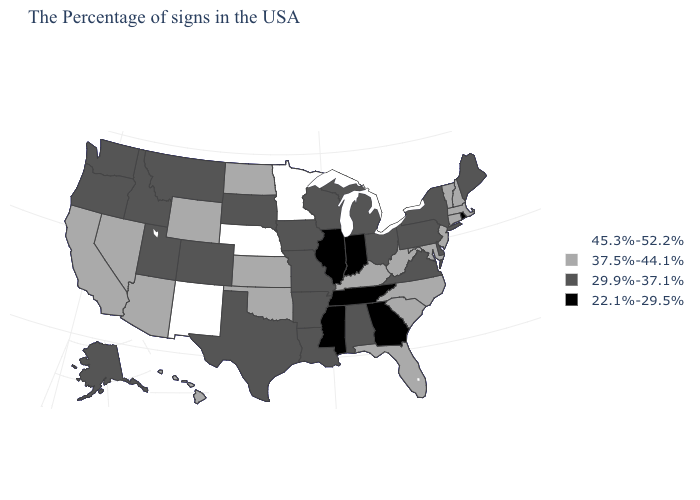Which states hav the highest value in the MidWest?
Give a very brief answer. Minnesota, Nebraska. What is the value of Delaware?
Concise answer only. 29.9%-37.1%. Which states have the lowest value in the USA?
Keep it brief. Rhode Island, Georgia, Indiana, Tennessee, Illinois, Mississippi. Name the states that have a value in the range 45.3%-52.2%?
Quick response, please. Minnesota, Nebraska, New Mexico. What is the value of Hawaii?
Be succinct. 37.5%-44.1%. Among the states that border Indiana , which have the highest value?
Concise answer only. Kentucky. Does Colorado have the lowest value in the USA?
Answer briefly. No. Does Oklahoma have a lower value than Massachusetts?
Be succinct. No. What is the value of Tennessee?
Short answer required. 22.1%-29.5%. Name the states that have a value in the range 29.9%-37.1%?
Answer briefly. Maine, New York, Delaware, Pennsylvania, Virginia, Ohio, Michigan, Alabama, Wisconsin, Louisiana, Missouri, Arkansas, Iowa, Texas, South Dakota, Colorado, Utah, Montana, Idaho, Washington, Oregon, Alaska. What is the value of Montana?
Concise answer only. 29.9%-37.1%. Name the states that have a value in the range 22.1%-29.5%?
Keep it brief. Rhode Island, Georgia, Indiana, Tennessee, Illinois, Mississippi. Name the states that have a value in the range 37.5%-44.1%?
Keep it brief. Massachusetts, New Hampshire, Vermont, Connecticut, New Jersey, Maryland, North Carolina, South Carolina, West Virginia, Florida, Kentucky, Kansas, Oklahoma, North Dakota, Wyoming, Arizona, Nevada, California, Hawaii. What is the lowest value in states that border Kansas?
Write a very short answer. 29.9%-37.1%. 